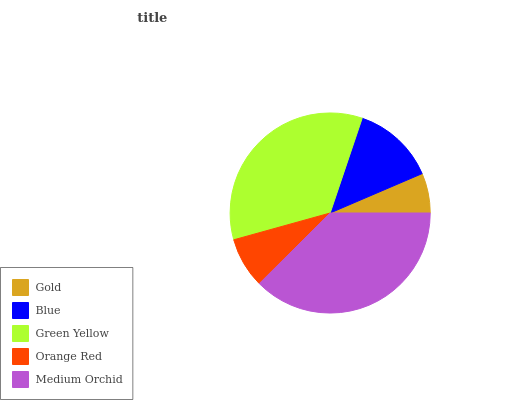Is Gold the minimum?
Answer yes or no. Yes. Is Medium Orchid the maximum?
Answer yes or no. Yes. Is Blue the minimum?
Answer yes or no. No. Is Blue the maximum?
Answer yes or no. No. Is Blue greater than Gold?
Answer yes or no. Yes. Is Gold less than Blue?
Answer yes or no. Yes. Is Gold greater than Blue?
Answer yes or no. No. Is Blue less than Gold?
Answer yes or no. No. Is Blue the high median?
Answer yes or no. Yes. Is Blue the low median?
Answer yes or no. Yes. Is Gold the high median?
Answer yes or no. No. Is Orange Red the low median?
Answer yes or no. No. 